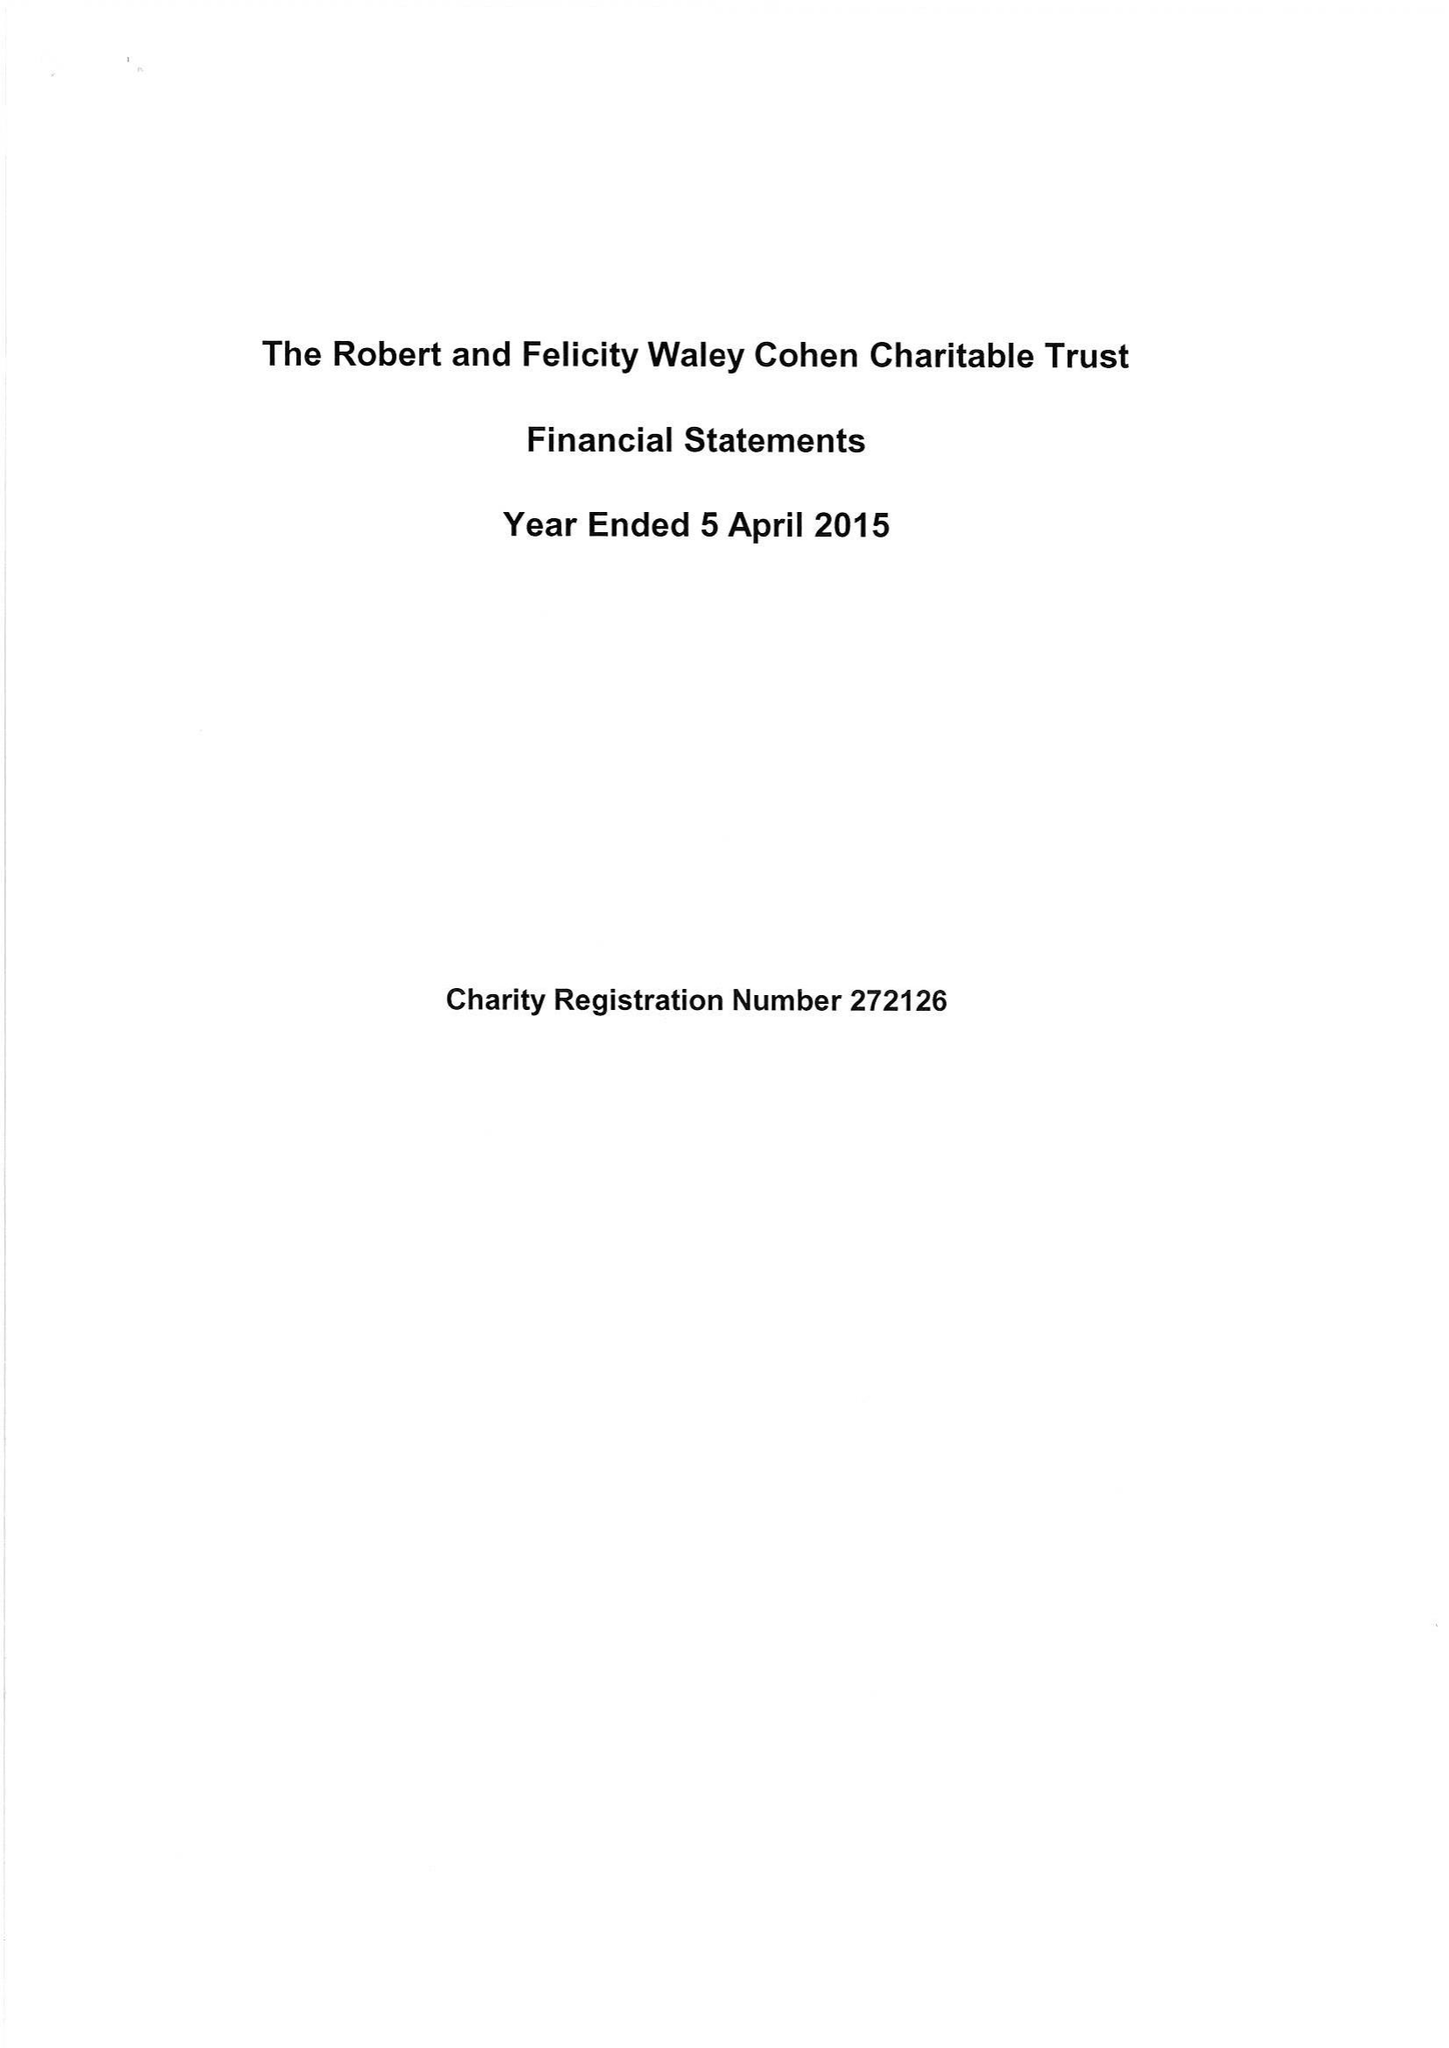What is the value for the charity_number?
Answer the question using a single word or phrase. 272126 